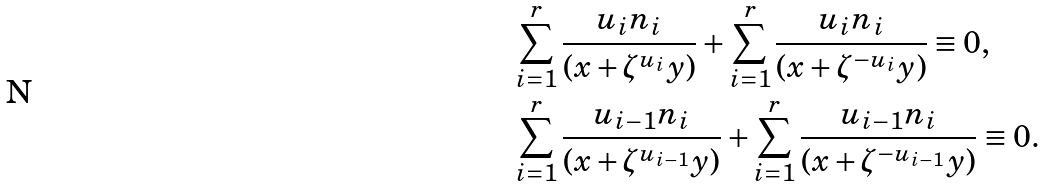<formula> <loc_0><loc_0><loc_500><loc_500>& \sum _ { i = 1 } ^ { r } \frac { u _ { i } n _ { i } } { ( x + \zeta ^ { u _ { i } } y ) } + \sum _ { i = 1 } ^ { r } \frac { u _ { i } n _ { i } } { ( x + \zeta ^ { - u _ { i } } y ) } \equiv 0 , \\ & \sum _ { i = 1 } ^ { r } \frac { u _ { i - 1 } n _ { i } } { ( x + \zeta ^ { u _ { i - 1 } } y ) } + \sum _ { i = 1 } ^ { r } \frac { u _ { i - 1 } n _ { i } } { ( x + \zeta ^ { - u _ { i - 1 } } y ) } \equiv 0 .</formula> 